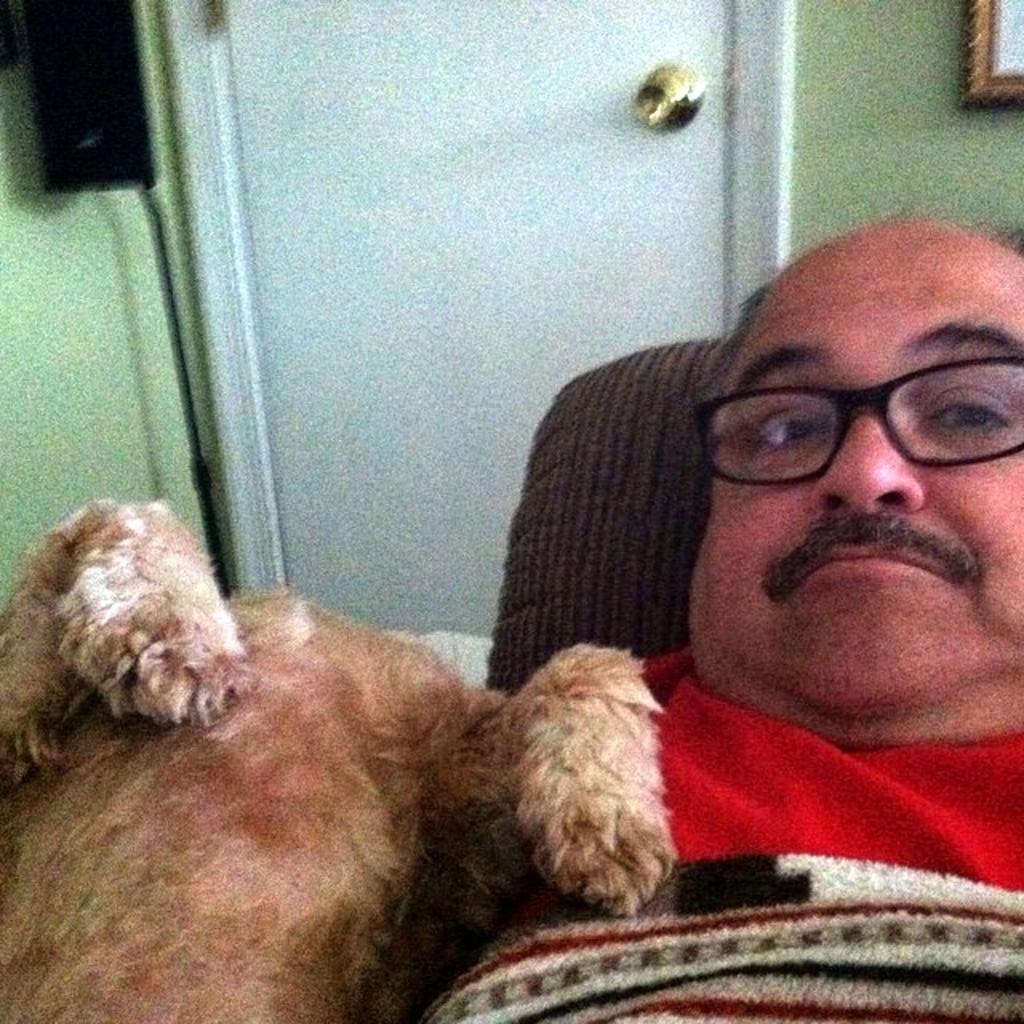Please provide a concise description of this image. In this image we can see a person lying on the surface. On the left side of the image we can see an animal and a speaker. In the background, we can see the photo frame on the wall and a door. 